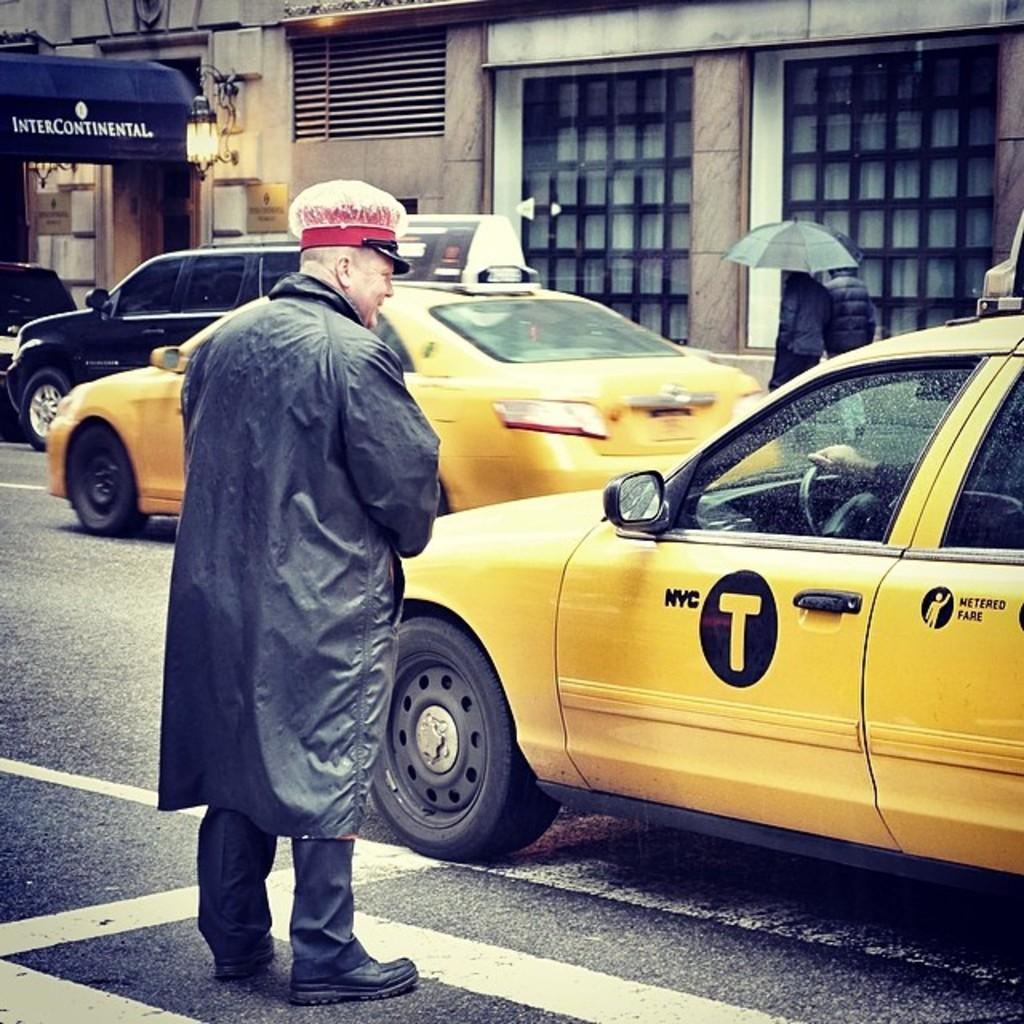Provide a one-sentence caption for the provided image. A man standing in the street talking to a person in a cab labeled NYC T. 